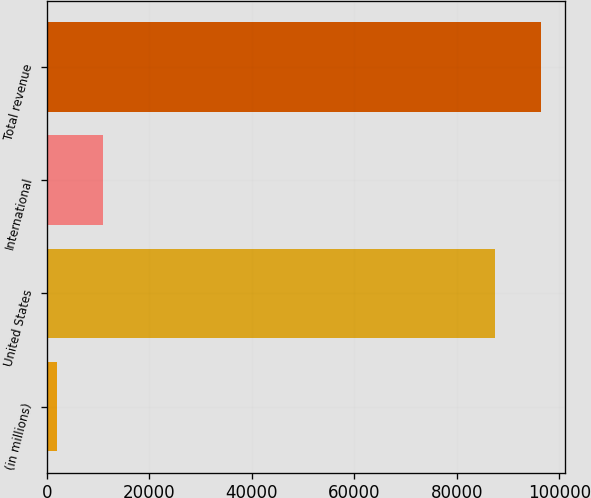Convert chart. <chart><loc_0><loc_0><loc_500><loc_500><bar_chart><fcel>(in millions)<fcel>United States<fcel>International<fcel>Total revenue<nl><fcel>2014<fcel>87449<fcel>10921<fcel>96356<nl></chart> 